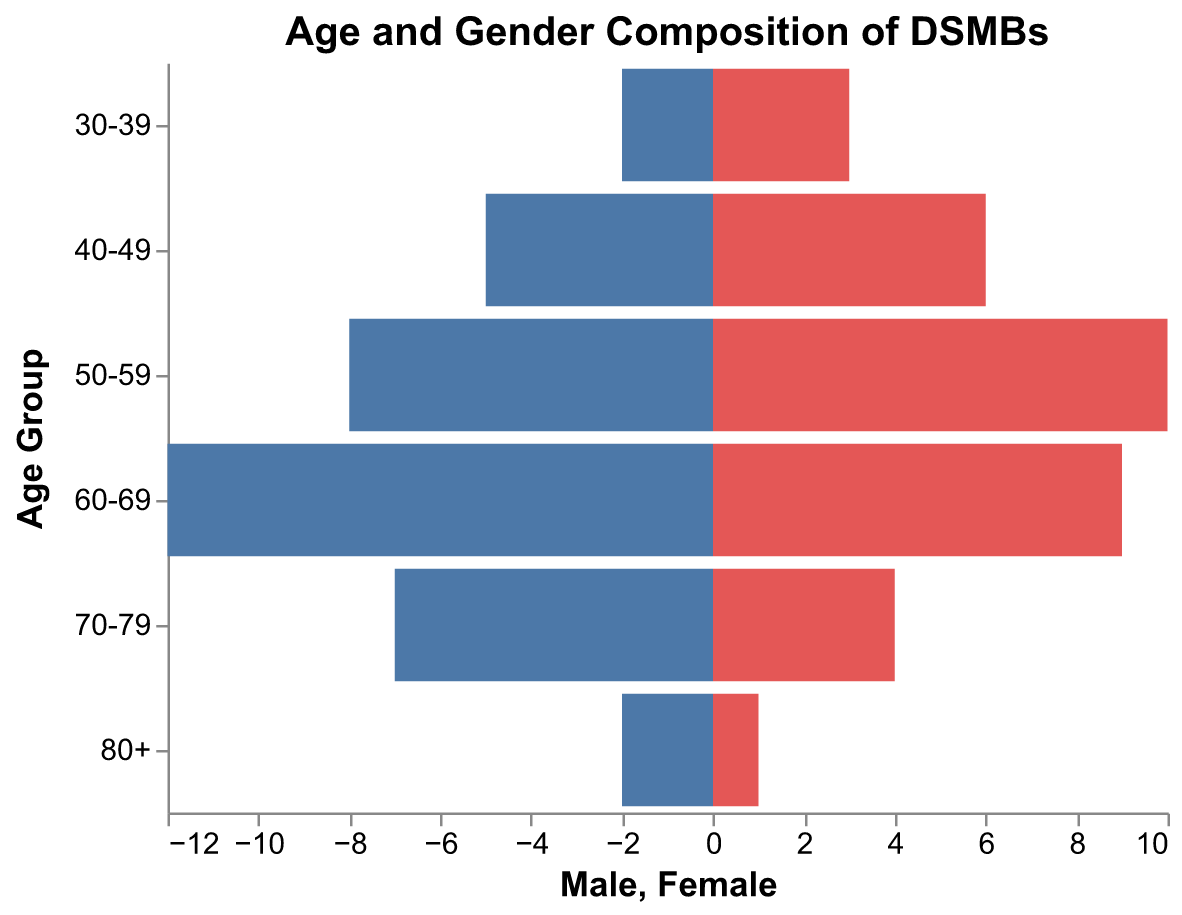What is the title of the figure? The title of the figure is displayed at the top and indicates the subject of the data represented in the figure.
Answer: Age and Gender Composition of DSMBs How many age groups are represented in the figure? The figure displays the number of unique age groups along the vertical axis.
Answer: 6 In the 60-69 age group, which gender has a higher count? By looking at the lengths of the bars corresponding to the 60-69 age group, the Male bar is longer than the Female bar.
Answer: Male What is the total count of females in the 70-79 age group? Refer to the length of the bar representing females in the 70-79 age group.
Answer: 4 What is the combined count of males and females aged 50-59? For this data point, sum the numbers given for males and females in the 50-59 age group: 8 (Male) + 10 (Female).
Answer: 18 Compare the gender with the lowest count in the 30-39 age group. Identify the shorter bar in the 30-39 age group; in this case, the Male count (2) is less than the Female count (3).
Answer: Male Which age group has the highest male count? By examining the lengths of the male bars across all age groups, the 60-69 age group has the longest male bar, indicating the highest count (12).
Answer: 60-69 How does the total number of females change from the 40-49 age group to the 50-59 age group? Subtract the number of females in the 40-49 age group (6) from the number of females in the 50-59 age group (10). The difference is 10 - 6.
Answer: Increases by 4 What is the average number of males across all age groups? Calculate the sum of the male counts across all age groups (2+5+8+12+7+2 = 36) and divide by the number of age groups (6).
Answer: 6 Which gender has a higher total count across all age groups? Sum the counts for each gender separately and compare. Females: 3+6+10+9+4+1 = 33; Males: 2+5+8+12+7+2 = 36.
Answer: Male 